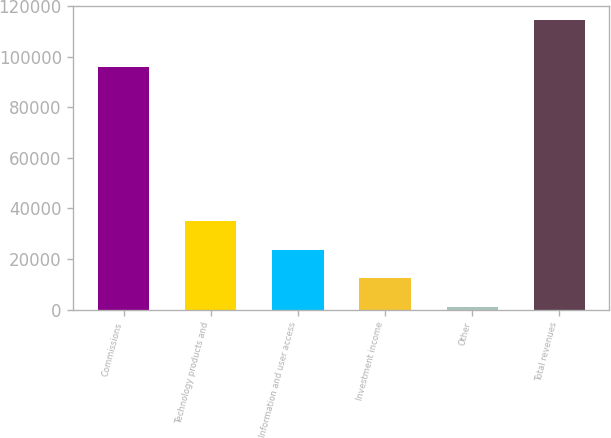Convert chart. <chart><loc_0><loc_0><loc_500><loc_500><bar_chart><fcel>Commissions<fcel>Technology products and<fcel>Information and user access<fcel>Investment income<fcel>Other<fcel>Total revenues<nl><fcel>96132<fcel>35070.2<fcel>23731.8<fcel>12393.4<fcel>1055<fcel>114439<nl></chart> 